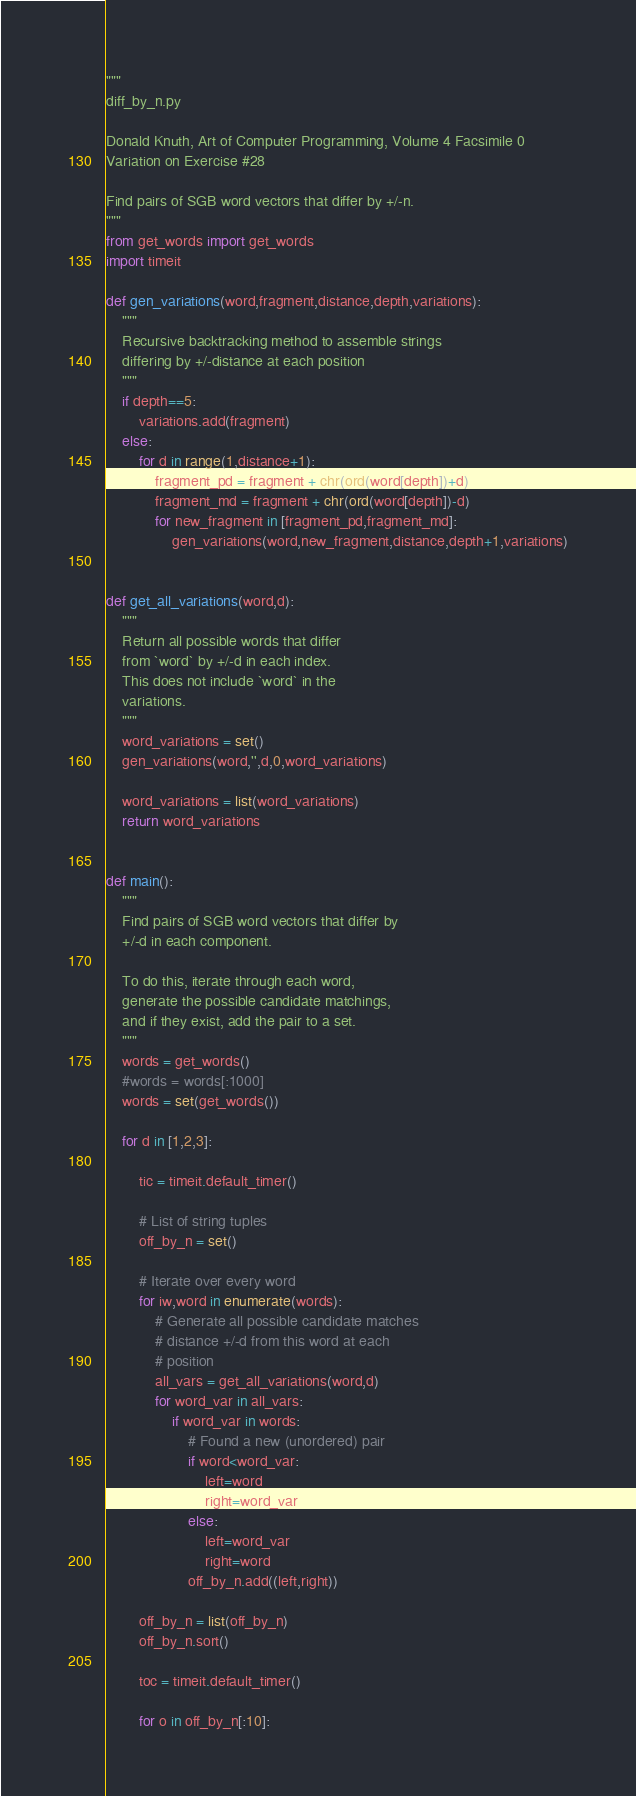Convert code to text. <code><loc_0><loc_0><loc_500><loc_500><_Python_>"""
diff_by_n.py

Donald Knuth, Art of Computer Programming, Volume 4 Facsimile 0
Variation on Exercise #28

Find pairs of SGB word vectors that differ by +/-n.
"""
from get_words import get_words
import timeit

def gen_variations(word,fragment,distance,depth,variations):
    """
    Recursive backtracking method to assemble strings
    differing by +/-distance at each position
    """
    if depth==5:
        variations.add(fragment)
    else:
        for d in range(1,distance+1):
            fragment_pd = fragment + chr(ord(word[depth])+d)
            fragment_md = fragment + chr(ord(word[depth])-d)
            for new_fragment in [fragment_pd,fragment_md]:
                gen_variations(word,new_fragment,distance,depth+1,variations)


def get_all_variations(word,d):
    """
    Return all possible words that differ
    from `word` by +/-d in each index.
    This does not include `word` in the 
    variations.
    """
    word_variations = set()
    gen_variations(word,'',d,0,word_variations)

    word_variations = list(word_variations)
    return word_variations


def main():
    """
    Find pairs of SGB word vectors that differ by 
    +/-d in each component.
    
    To do this, iterate through each word,
    generate the possible candidate matchings,
    and if they exist, add the pair to a set.
    """
    words = get_words()
    #words = words[:1000]
    words = set(get_words())

    for d in [1,2,3]:

        tic = timeit.default_timer()

        # List of string tuples
        off_by_n = set()

        # Iterate over every word
        for iw,word in enumerate(words):
            # Generate all possible candidate matches
            # distance +/-d from this word at each
            # position
            all_vars = get_all_variations(word,d)
            for word_var in all_vars:
                if word_var in words:
                    # Found a new (unordered) pair
                    if word<word_var:
                        left=word
                        right=word_var
                    else:
                        left=word_var
                        right=word
                    off_by_n.add((left,right))
        
        off_by_n = list(off_by_n)
        off_by_n.sort()

        toc = timeit.default_timer()

        for o in off_by_n[:10]:</code> 